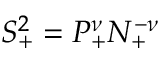Convert formula to latex. <formula><loc_0><loc_0><loc_500><loc_500>S _ { + } ^ { 2 } = P _ { + } ^ { \nu } N _ { + } ^ { - \nu }</formula> 